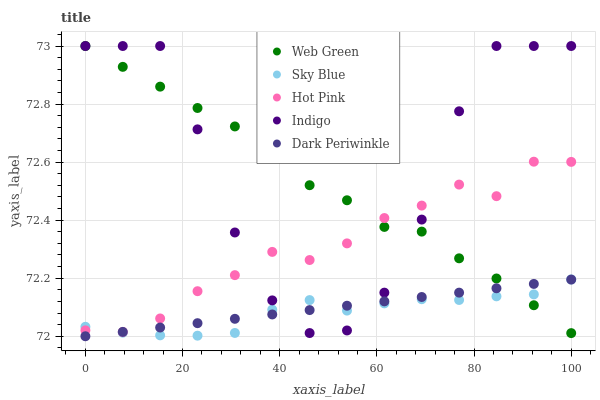Does Sky Blue have the minimum area under the curve?
Answer yes or no. Yes. Does Indigo have the maximum area under the curve?
Answer yes or no. Yes. Does Hot Pink have the minimum area under the curve?
Answer yes or no. No. Does Hot Pink have the maximum area under the curve?
Answer yes or no. No. Is Dark Periwinkle the smoothest?
Answer yes or no. Yes. Is Indigo the roughest?
Answer yes or no. Yes. Is Hot Pink the smoothest?
Answer yes or no. No. Is Hot Pink the roughest?
Answer yes or no. No. Does Dark Periwinkle have the lowest value?
Answer yes or no. Yes. Does Indigo have the lowest value?
Answer yes or no. No. Does Web Green have the highest value?
Answer yes or no. Yes. Does Hot Pink have the highest value?
Answer yes or no. No. Does Indigo intersect Dark Periwinkle?
Answer yes or no. Yes. Is Indigo less than Dark Periwinkle?
Answer yes or no. No. Is Indigo greater than Dark Periwinkle?
Answer yes or no. No. 